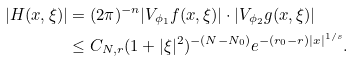Convert formula to latex. <formula><loc_0><loc_0><loc_500><loc_500>| H ( x , \xi ) | & = ( 2 \pi ) ^ { - n } | V _ { \phi _ { 1 } } f ( x , \xi ) | \cdot | V _ { \phi _ { 2 } } g ( x , \xi ) | \\ & \leq C _ { N , r } ( 1 + | \xi | ^ { 2 } ) ^ { - ( N - N _ { 0 } ) } e ^ { - ( r _ { 0 } - r ) | x | ^ { 1 / s } } .</formula> 